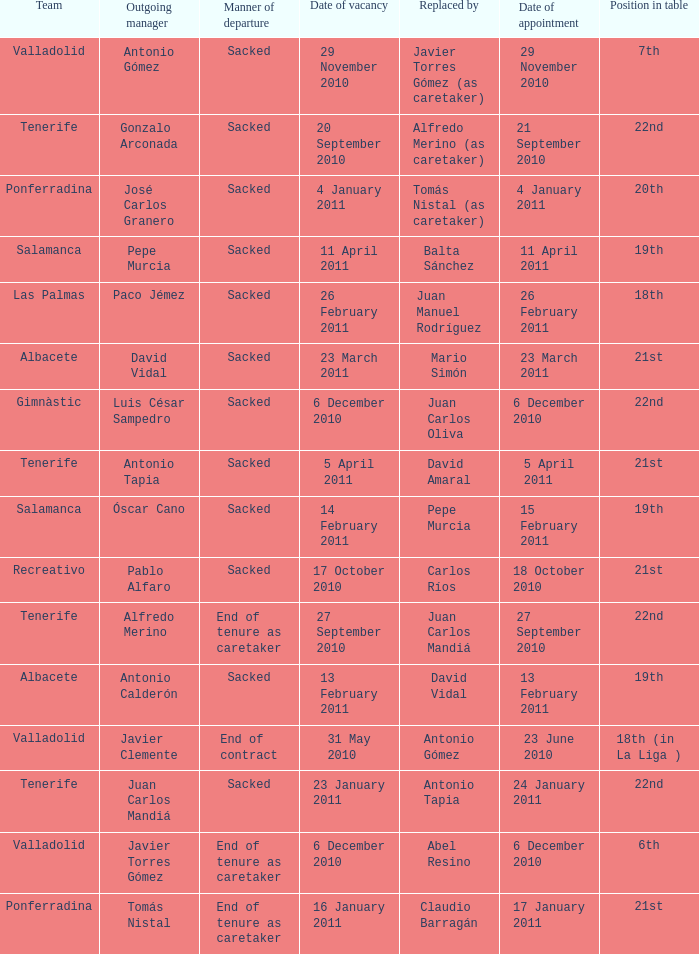What was the appointment date for outgoing manager luis césar sampedro 6 December 2010. 